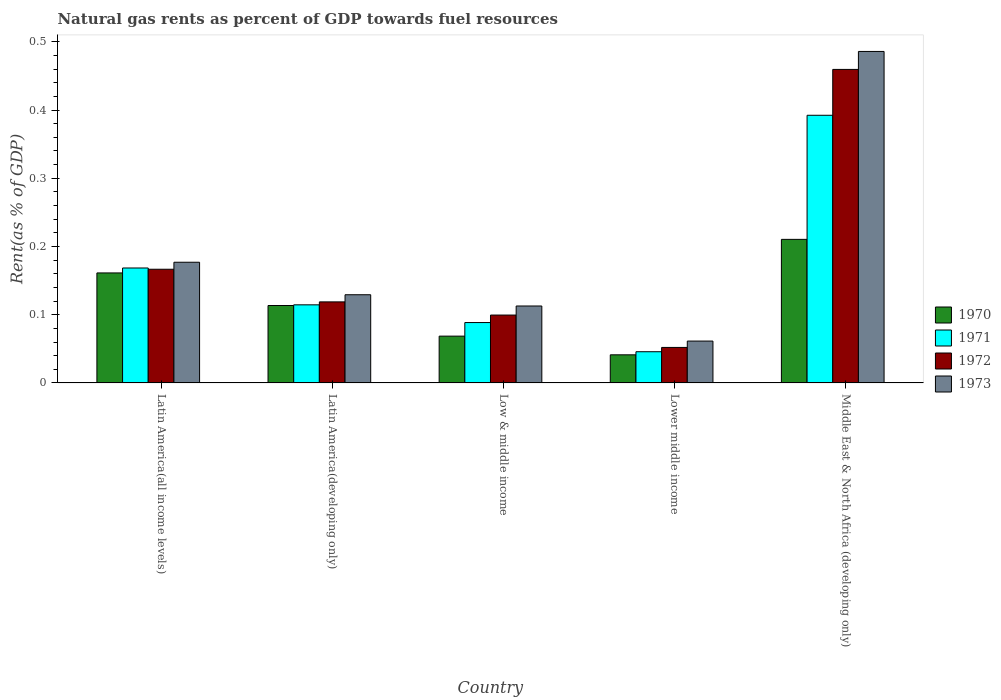Are the number of bars per tick equal to the number of legend labels?
Give a very brief answer. Yes. Are the number of bars on each tick of the X-axis equal?
Your answer should be compact. Yes. How many bars are there on the 4th tick from the left?
Offer a terse response. 4. How many bars are there on the 5th tick from the right?
Provide a short and direct response. 4. What is the label of the 5th group of bars from the left?
Your answer should be very brief. Middle East & North Africa (developing only). What is the matural gas rent in 1971 in Latin America(all income levels)?
Your answer should be very brief. 0.17. Across all countries, what is the maximum matural gas rent in 1972?
Give a very brief answer. 0.46. Across all countries, what is the minimum matural gas rent in 1971?
Offer a terse response. 0.05. In which country was the matural gas rent in 1972 maximum?
Ensure brevity in your answer.  Middle East & North Africa (developing only). In which country was the matural gas rent in 1973 minimum?
Provide a succinct answer. Lower middle income. What is the total matural gas rent in 1970 in the graph?
Your answer should be compact. 0.6. What is the difference between the matural gas rent in 1973 in Latin America(developing only) and that in Middle East & North Africa (developing only)?
Your answer should be very brief. -0.36. What is the difference between the matural gas rent in 1973 in Latin America(all income levels) and the matural gas rent in 1970 in Low & middle income?
Your answer should be compact. 0.11. What is the average matural gas rent in 1970 per country?
Ensure brevity in your answer.  0.12. What is the difference between the matural gas rent of/in 1971 and matural gas rent of/in 1973 in Latin America(all income levels)?
Offer a terse response. -0.01. In how many countries, is the matural gas rent in 1970 greater than 0.48000000000000004 %?
Your response must be concise. 0. What is the ratio of the matural gas rent in 1971 in Low & middle income to that in Middle East & North Africa (developing only)?
Your answer should be compact. 0.23. What is the difference between the highest and the second highest matural gas rent in 1972?
Your answer should be very brief. 0.34. What is the difference between the highest and the lowest matural gas rent in 1970?
Keep it short and to the point. 0.17. Is the sum of the matural gas rent in 1972 in Latin America(developing only) and Lower middle income greater than the maximum matural gas rent in 1971 across all countries?
Ensure brevity in your answer.  No. Is it the case that in every country, the sum of the matural gas rent in 1971 and matural gas rent in 1972 is greater than the sum of matural gas rent in 1973 and matural gas rent in 1970?
Provide a short and direct response. No. What does the 4th bar from the left in Lower middle income represents?
Offer a terse response. 1973. What does the 4th bar from the right in Latin America(developing only) represents?
Offer a terse response. 1970. Is it the case that in every country, the sum of the matural gas rent in 1971 and matural gas rent in 1970 is greater than the matural gas rent in 1972?
Provide a succinct answer. Yes. How many bars are there?
Your response must be concise. 20. How many countries are there in the graph?
Make the answer very short. 5. What is the difference between two consecutive major ticks on the Y-axis?
Make the answer very short. 0.1. Does the graph contain grids?
Your answer should be compact. No. Where does the legend appear in the graph?
Your response must be concise. Center right. How many legend labels are there?
Provide a succinct answer. 4. How are the legend labels stacked?
Offer a terse response. Vertical. What is the title of the graph?
Your answer should be compact. Natural gas rents as percent of GDP towards fuel resources. What is the label or title of the Y-axis?
Provide a succinct answer. Rent(as % of GDP). What is the Rent(as % of GDP) in 1970 in Latin America(all income levels)?
Your response must be concise. 0.16. What is the Rent(as % of GDP) in 1971 in Latin America(all income levels)?
Offer a very short reply. 0.17. What is the Rent(as % of GDP) of 1972 in Latin America(all income levels)?
Keep it short and to the point. 0.17. What is the Rent(as % of GDP) of 1973 in Latin America(all income levels)?
Provide a succinct answer. 0.18. What is the Rent(as % of GDP) of 1970 in Latin America(developing only)?
Make the answer very short. 0.11. What is the Rent(as % of GDP) in 1971 in Latin America(developing only)?
Give a very brief answer. 0.11. What is the Rent(as % of GDP) of 1972 in Latin America(developing only)?
Your answer should be very brief. 0.12. What is the Rent(as % of GDP) of 1973 in Latin America(developing only)?
Ensure brevity in your answer.  0.13. What is the Rent(as % of GDP) in 1970 in Low & middle income?
Your answer should be compact. 0.07. What is the Rent(as % of GDP) in 1971 in Low & middle income?
Make the answer very short. 0.09. What is the Rent(as % of GDP) in 1972 in Low & middle income?
Your answer should be very brief. 0.1. What is the Rent(as % of GDP) in 1973 in Low & middle income?
Give a very brief answer. 0.11. What is the Rent(as % of GDP) of 1970 in Lower middle income?
Give a very brief answer. 0.04. What is the Rent(as % of GDP) in 1971 in Lower middle income?
Keep it short and to the point. 0.05. What is the Rent(as % of GDP) of 1972 in Lower middle income?
Provide a short and direct response. 0.05. What is the Rent(as % of GDP) in 1973 in Lower middle income?
Offer a terse response. 0.06. What is the Rent(as % of GDP) in 1970 in Middle East & North Africa (developing only)?
Keep it short and to the point. 0.21. What is the Rent(as % of GDP) in 1971 in Middle East & North Africa (developing only)?
Your response must be concise. 0.39. What is the Rent(as % of GDP) in 1972 in Middle East & North Africa (developing only)?
Give a very brief answer. 0.46. What is the Rent(as % of GDP) of 1973 in Middle East & North Africa (developing only)?
Keep it short and to the point. 0.49. Across all countries, what is the maximum Rent(as % of GDP) of 1970?
Provide a succinct answer. 0.21. Across all countries, what is the maximum Rent(as % of GDP) of 1971?
Provide a succinct answer. 0.39. Across all countries, what is the maximum Rent(as % of GDP) in 1972?
Your response must be concise. 0.46. Across all countries, what is the maximum Rent(as % of GDP) in 1973?
Offer a very short reply. 0.49. Across all countries, what is the minimum Rent(as % of GDP) of 1970?
Offer a very short reply. 0.04. Across all countries, what is the minimum Rent(as % of GDP) in 1971?
Make the answer very short. 0.05. Across all countries, what is the minimum Rent(as % of GDP) in 1972?
Provide a succinct answer. 0.05. Across all countries, what is the minimum Rent(as % of GDP) of 1973?
Offer a very short reply. 0.06. What is the total Rent(as % of GDP) in 1970 in the graph?
Provide a short and direct response. 0.59. What is the total Rent(as % of GDP) in 1971 in the graph?
Provide a succinct answer. 0.81. What is the total Rent(as % of GDP) in 1972 in the graph?
Provide a succinct answer. 0.9. What is the total Rent(as % of GDP) in 1973 in the graph?
Your answer should be compact. 0.97. What is the difference between the Rent(as % of GDP) in 1970 in Latin America(all income levels) and that in Latin America(developing only)?
Keep it short and to the point. 0.05. What is the difference between the Rent(as % of GDP) in 1971 in Latin America(all income levels) and that in Latin America(developing only)?
Ensure brevity in your answer.  0.05. What is the difference between the Rent(as % of GDP) in 1972 in Latin America(all income levels) and that in Latin America(developing only)?
Provide a short and direct response. 0.05. What is the difference between the Rent(as % of GDP) in 1973 in Latin America(all income levels) and that in Latin America(developing only)?
Offer a very short reply. 0.05. What is the difference between the Rent(as % of GDP) of 1970 in Latin America(all income levels) and that in Low & middle income?
Offer a very short reply. 0.09. What is the difference between the Rent(as % of GDP) of 1971 in Latin America(all income levels) and that in Low & middle income?
Offer a terse response. 0.08. What is the difference between the Rent(as % of GDP) in 1972 in Latin America(all income levels) and that in Low & middle income?
Ensure brevity in your answer.  0.07. What is the difference between the Rent(as % of GDP) of 1973 in Latin America(all income levels) and that in Low & middle income?
Your answer should be compact. 0.06. What is the difference between the Rent(as % of GDP) of 1970 in Latin America(all income levels) and that in Lower middle income?
Offer a terse response. 0.12. What is the difference between the Rent(as % of GDP) of 1971 in Latin America(all income levels) and that in Lower middle income?
Your answer should be very brief. 0.12. What is the difference between the Rent(as % of GDP) of 1972 in Latin America(all income levels) and that in Lower middle income?
Make the answer very short. 0.11. What is the difference between the Rent(as % of GDP) of 1973 in Latin America(all income levels) and that in Lower middle income?
Offer a very short reply. 0.12. What is the difference between the Rent(as % of GDP) in 1970 in Latin America(all income levels) and that in Middle East & North Africa (developing only)?
Give a very brief answer. -0.05. What is the difference between the Rent(as % of GDP) of 1971 in Latin America(all income levels) and that in Middle East & North Africa (developing only)?
Your response must be concise. -0.22. What is the difference between the Rent(as % of GDP) of 1972 in Latin America(all income levels) and that in Middle East & North Africa (developing only)?
Keep it short and to the point. -0.29. What is the difference between the Rent(as % of GDP) of 1973 in Latin America(all income levels) and that in Middle East & North Africa (developing only)?
Keep it short and to the point. -0.31. What is the difference between the Rent(as % of GDP) in 1970 in Latin America(developing only) and that in Low & middle income?
Your answer should be compact. 0.04. What is the difference between the Rent(as % of GDP) in 1971 in Latin America(developing only) and that in Low & middle income?
Your answer should be very brief. 0.03. What is the difference between the Rent(as % of GDP) of 1972 in Latin America(developing only) and that in Low & middle income?
Offer a very short reply. 0.02. What is the difference between the Rent(as % of GDP) in 1973 in Latin America(developing only) and that in Low & middle income?
Provide a short and direct response. 0.02. What is the difference between the Rent(as % of GDP) of 1970 in Latin America(developing only) and that in Lower middle income?
Ensure brevity in your answer.  0.07. What is the difference between the Rent(as % of GDP) in 1971 in Latin America(developing only) and that in Lower middle income?
Provide a short and direct response. 0.07. What is the difference between the Rent(as % of GDP) in 1972 in Latin America(developing only) and that in Lower middle income?
Your response must be concise. 0.07. What is the difference between the Rent(as % of GDP) in 1973 in Latin America(developing only) and that in Lower middle income?
Provide a succinct answer. 0.07. What is the difference between the Rent(as % of GDP) in 1970 in Latin America(developing only) and that in Middle East & North Africa (developing only)?
Offer a terse response. -0.1. What is the difference between the Rent(as % of GDP) in 1971 in Latin America(developing only) and that in Middle East & North Africa (developing only)?
Give a very brief answer. -0.28. What is the difference between the Rent(as % of GDP) in 1972 in Latin America(developing only) and that in Middle East & North Africa (developing only)?
Give a very brief answer. -0.34. What is the difference between the Rent(as % of GDP) in 1973 in Latin America(developing only) and that in Middle East & North Africa (developing only)?
Offer a very short reply. -0.36. What is the difference between the Rent(as % of GDP) in 1970 in Low & middle income and that in Lower middle income?
Provide a short and direct response. 0.03. What is the difference between the Rent(as % of GDP) in 1971 in Low & middle income and that in Lower middle income?
Your answer should be compact. 0.04. What is the difference between the Rent(as % of GDP) in 1972 in Low & middle income and that in Lower middle income?
Give a very brief answer. 0.05. What is the difference between the Rent(as % of GDP) in 1973 in Low & middle income and that in Lower middle income?
Your answer should be very brief. 0.05. What is the difference between the Rent(as % of GDP) of 1970 in Low & middle income and that in Middle East & North Africa (developing only)?
Offer a very short reply. -0.14. What is the difference between the Rent(as % of GDP) in 1971 in Low & middle income and that in Middle East & North Africa (developing only)?
Your answer should be very brief. -0.3. What is the difference between the Rent(as % of GDP) of 1972 in Low & middle income and that in Middle East & North Africa (developing only)?
Offer a very short reply. -0.36. What is the difference between the Rent(as % of GDP) in 1973 in Low & middle income and that in Middle East & North Africa (developing only)?
Your answer should be compact. -0.37. What is the difference between the Rent(as % of GDP) in 1970 in Lower middle income and that in Middle East & North Africa (developing only)?
Offer a very short reply. -0.17. What is the difference between the Rent(as % of GDP) in 1971 in Lower middle income and that in Middle East & North Africa (developing only)?
Give a very brief answer. -0.35. What is the difference between the Rent(as % of GDP) in 1972 in Lower middle income and that in Middle East & North Africa (developing only)?
Make the answer very short. -0.41. What is the difference between the Rent(as % of GDP) of 1973 in Lower middle income and that in Middle East & North Africa (developing only)?
Make the answer very short. -0.42. What is the difference between the Rent(as % of GDP) of 1970 in Latin America(all income levels) and the Rent(as % of GDP) of 1971 in Latin America(developing only)?
Your answer should be compact. 0.05. What is the difference between the Rent(as % of GDP) in 1970 in Latin America(all income levels) and the Rent(as % of GDP) in 1972 in Latin America(developing only)?
Your answer should be compact. 0.04. What is the difference between the Rent(as % of GDP) in 1970 in Latin America(all income levels) and the Rent(as % of GDP) in 1973 in Latin America(developing only)?
Give a very brief answer. 0.03. What is the difference between the Rent(as % of GDP) of 1971 in Latin America(all income levels) and the Rent(as % of GDP) of 1972 in Latin America(developing only)?
Provide a short and direct response. 0.05. What is the difference between the Rent(as % of GDP) in 1971 in Latin America(all income levels) and the Rent(as % of GDP) in 1973 in Latin America(developing only)?
Keep it short and to the point. 0.04. What is the difference between the Rent(as % of GDP) in 1972 in Latin America(all income levels) and the Rent(as % of GDP) in 1973 in Latin America(developing only)?
Your response must be concise. 0.04. What is the difference between the Rent(as % of GDP) of 1970 in Latin America(all income levels) and the Rent(as % of GDP) of 1971 in Low & middle income?
Your answer should be very brief. 0.07. What is the difference between the Rent(as % of GDP) in 1970 in Latin America(all income levels) and the Rent(as % of GDP) in 1972 in Low & middle income?
Offer a terse response. 0.06. What is the difference between the Rent(as % of GDP) in 1970 in Latin America(all income levels) and the Rent(as % of GDP) in 1973 in Low & middle income?
Ensure brevity in your answer.  0.05. What is the difference between the Rent(as % of GDP) in 1971 in Latin America(all income levels) and the Rent(as % of GDP) in 1972 in Low & middle income?
Provide a short and direct response. 0.07. What is the difference between the Rent(as % of GDP) in 1971 in Latin America(all income levels) and the Rent(as % of GDP) in 1973 in Low & middle income?
Make the answer very short. 0.06. What is the difference between the Rent(as % of GDP) in 1972 in Latin America(all income levels) and the Rent(as % of GDP) in 1973 in Low & middle income?
Give a very brief answer. 0.05. What is the difference between the Rent(as % of GDP) of 1970 in Latin America(all income levels) and the Rent(as % of GDP) of 1971 in Lower middle income?
Offer a very short reply. 0.12. What is the difference between the Rent(as % of GDP) in 1970 in Latin America(all income levels) and the Rent(as % of GDP) in 1972 in Lower middle income?
Your response must be concise. 0.11. What is the difference between the Rent(as % of GDP) of 1970 in Latin America(all income levels) and the Rent(as % of GDP) of 1973 in Lower middle income?
Offer a terse response. 0.1. What is the difference between the Rent(as % of GDP) in 1971 in Latin America(all income levels) and the Rent(as % of GDP) in 1972 in Lower middle income?
Offer a very short reply. 0.12. What is the difference between the Rent(as % of GDP) in 1971 in Latin America(all income levels) and the Rent(as % of GDP) in 1973 in Lower middle income?
Your answer should be very brief. 0.11. What is the difference between the Rent(as % of GDP) of 1972 in Latin America(all income levels) and the Rent(as % of GDP) of 1973 in Lower middle income?
Ensure brevity in your answer.  0.11. What is the difference between the Rent(as % of GDP) of 1970 in Latin America(all income levels) and the Rent(as % of GDP) of 1971 in Middle East & North Africa (developing only)?
Offer a very short reply. -0.23. What is the difference between the Rent(as % of GDP) in 1970 in Latin America(all income levels) and the Rent(as % of GDP) in 1972 in Middle East & North Africa (developing only)?
Ensure brevity in your answer.  -0.3. What is the difference between the Rent(as % of GDP) in 1970 in Latin America(all income levels) and the Rent(as % of GDP) in 1973 in Middle East & North Africa (developing only)?
Offer a terse response. -0.32. What is the difference between the Rent(as % of GDP) of 1971 in Latin America(all income levels) and the Rent(as % of GDP) of 1972 in Middle East & North Africa (developing only)?
Offer a terse response. -0.29. What is the difference between the Rent(as % of GDP) of 1971 in Latin America(all income levels) and the Rent(as % of GDP) of 1973 in Middle East & North Africa (developing only)?
Give a very brief answer. -0.32. What is the difference between the Rent(as % of GDP) of 1972 in Latin America(all income levels) and the Rent(as % of GDP) of 1973 in Middle East & North Africa (developing only)?
Ensure brevity in your answer.  -0.32. What is the difference between the Rent(as % of GDP) of 1970 in Latin America(developing only) and the Rent(as % of GDP) of 1971 in Low & middle income?
Offer a very short reply. 0.03. What is the difference between the Rent(as % of GDP) of 1970 in Latin America(developing only) and the Rent(as % of GDP) of 1972 in Low & middle income?
Keep it short and to the point. 0.01. What is the difference between the Rent(as % of GDP) in 1970 in Latin America(developing only) and the Rent(as % of GDP) in 1973 in Low & middle income?
Offer a very short reply. 0. What is the difference between the Rent(as % of GDP) in 1971 in Latin America(developing only) and the Rent(as % of GDP) in 1972 in Low & middle income?
Offer a very short reply. 0.01. What is the difference between the Rent(as % of GDP) of 1971 in Latin America(developing only) and the Rent(as % of GDP) of 1973 in Low & middle income?
Offer a very short reply. 0. What is the difference between the Rent(as % of GDP) of 1972 in Latin America(developing only) and the Rent(as % of GDP) of 1973 in Low & middle income?
Give a very brief answer. 0.01. What is the difference between the Rent(as % of GDP) of 1970 in Latin America(developing only) and the Rent(as % of GDP) of 1971 in Lower middle income?
Your answer should be very brief. 0.07. What is the difference between the Rent(as % of GDP) of 1970 in Latin America(developing only) and the Rent(as % of GDP) of 1972 in Lower middle income?
Your response must be concise. 0.06. What is the difference between the Rent(as % of GDP) in 1970 in Latin America(developing only) and the Rent(as % of GDP) in 1973 in Lower middle income?
Keep it short and to the point. 0.05. What is the difference between the Rent(as % of GDP) of 1971 in Latin America(developing only) and the Rent(as % of GDP) of 1972 in Lower middle income?
Ensure brevity in your answer.  0.06. What is the difference between the Rent(as % of GDP) in 1971 in Latin America(developing only) and the Rent(as % of GDP) in 1973 in Lower middle income?
Make the answer very short. 0.05. What is the difference between the Rent(as % of GDP) in 1972 in Latin America(developing only) and the Rent(as % of GDP) in 1973 in Lower middle income?
Offer a terse response. 0.06. What is the difference between the Rent(as % of GDP) in 1970 in Latin America(developing only) and the Rent(as % of GDP) in 1971 in Middle East & North Africa (developing only)?
Provide a short and direct response. -0.28. What is the difference between the Rent(as % of GDP) of 1970 in Latin America(developing only) and the Rent(as % of GDP) of 1972 in Middle East & North Africa (developing only)?
Give a very brief answer. -0.35. What is the difference between the Rent(as % of GDP) of 1970 in Latin America(developing only) and the Rent(as % of GDP) of 1973 in Middle East & North Africa (developing only)?
Ensure brevity in your answer.  -0.37. What is the difference between the Rent(as % of GDP) of 1971 in Latin America(developing only) and the Rent(as % of GDP) of 1972 in Middle East & North Africa (developing only)?
Make the answer very short. -0.35. What is the difference between the Rent(as % of GDP) of 1971 in Latin America(developing only) and the Rent(as % of GDP) of 1973 in Middle East & North Africa (developing only)?
Your answer should be very brief. -0.37. What is the difference between the Rent(as % of GDP) in 1972 in Latin America(developing only) and the Rent(as % of GDP) in 1973 in Middle East & North Africa (developing only)?
Offer a very short reply. -0.37. What is the difference between the Rent(as % of GDP) in 1970 in Low & middle income and the Rent(as % of GDP) in 1971 in Lower middle income?
Your answer should be compact. 0.02. What is the difference between the Rent(as % of GDP) in 1970 in Low & middle income and the Rent(as % of GDP) in 1972 in Lower middle income?
Your answer should be very brief. 0.02. What is the difference between the Rent(as % of GDP) of 1970 in Low & middle income and the Rent(as % of GDP) of 1973 in Lower middle income?
Make the answer very short. 0.01. What is the difference between the Rent(as % of GDP) of 1971 in Low & middle income and the Rent(as % of GDP) of 1972 in Lower middle income?
Keep it short and to the point. 0.04. What is the difference between the Rent(as % of GDP) in 1971 in Low & middle income and the Rent(as % of GDP) in 1973 in Lower middle income?
Your answer should be compact. 0.03. What is the difference between the Rent(as % of GDP) in 1972 in Low & middle income and the Rent(as % of GDP) in 1973 in Lower middle income?
Offer a terse response. 0.04. What is the difference between the Rent(as % of GDP) of 1970 in Low & middle income and the Rent(as % of GDP) of 1971 in Middle East & North Africa (developing only)?
Make the answer very short. -0.32. What is the difference between the Rent(as % of GDP) in 1970 in Low & middle income and the Rent(as % of GDP) in 1972 in Middle East & North Africa (developing only)?
Offer a terse response. -0.39. What is the difference between the Rent(as % of GDP) of 1970 in Low & middle income and the Rent(as % of GDP) of 1973 in Middle East & North Africa (developing only)?
Make the answer very short. -0.42. What is the difference between the Rent(as % of GDP) in 1971 in Low & middle income and the Rent(as % of GDP) in 1972 in Middle East & North Africa (developing only)?
Your response must be concise. -0.37. What is the difference between the Rent(as % of GDP) of 1971 in Low & middle income and the Rent(as % of GDP) of 1973 in Middle East & North Africa (developing only)?
Your answer should be compact. -0.4. What is the difference between the Rent(as % of GDP) in 1972 in Low & middle income and the Rent(as % of GDP) in 1973 in Middle East & North Africa (developing only)?
Your answer should be compact. -0.39. What is the difference between the Rent(as % of GDP) in 1970 in Lower middle income and the Rent(as % of GDP) in 1971 in Middle East & North Africa (developing only)?
Your response must be concise. -0.35. What is the difference between the Rent(as % of GDP) of 1970 in Lower middle income and the Rent(as % of GDP) of 1972 in Middle East & North Africa (developing only)?
Make the answer very short. -0.42. What is the difference between the Rent(as % of GDP) in 1970 in Lower middle income and the Rent(as % of GDP) in 1973 in Middle East & North Africa (developing only)?
Give a very brief answer. -0.44. What is the difference between the Rent(as % of GDP) of 1971 in Lower middle income and the Rent(as % of GDP) of 1972 in Middle East & North Africa (developing only)?
Offer a terse response. -0.41. What is the difference between the Rent(as % of GDP) in 1971 in Lower middle income and the Rent(as % of GDP) in 1973 in Middle East & North Africa (developing only)?
Make the answer very short. -0.44. What is the difference between the Rent(as % of GDP) of 1972 in Lower middle income and the Rent(as % of GDP) of 1973 in Middle East & North Africa (developing only)?
Keep it short and to the point. -0.43. What is the average Rent(as % of GDP) of 1970 per country?
Offer a very short reply. 0.12. What is the average Rent(as % of GDP) of 1971 per country?
Offer a terse response. 0.16. What is the average Rent(as % of GDP) in 1972 per country?
Ensure brevity in your answer.  0.18. What is the average Rent(as % of GDP) in 1973 per country?
Give a very brief answer. 0.19. What is the difference between the Rent(as % of GDP) in 1970 and Rent(as % of GDP) in 1971 in Latin America(all income levels)?
Make the answer very short. -0.01. What is the difference between the Rent(as % of GDP) of 1970 and Rent(as % of GDP) of 1972 in Latin America(all income levels)?
Offer a very short reply. -0.01. What is the difference between the Rent(as % of GDP) of 1970 and Rent(as % of GDP) of 1973 in Latin America(all income levels)?
Keep it short and to the point. -0.02. What is the difference between the Rent(as % of GDP) in 1971 and Rent(as % of GDP) in 1972 in Latin America(all income levels)?
Provide a short and direct response. 0. What is the difference between the Rent(as % of GDP) of 1971 and Rent(as % of GDP) of 1973 in Latin America(all income levels)?
Provide a short and direct response. -0.01. What is the difference between the Rent(as % of GDP) in 1972 and Rent(as % of GDP) in 1973 in Latin America(all income levels)?
Your answer should be compact. -0.01. What is the difference between the Rent(as % of GDP) in 1970 and Rent(as % of GDP) in 1971 in Latin America(developing only)?
Offer a terse response. -0. What is the difference between the Rent(as % of GDP) in 1970 and Rent(as % of GDP) in 1972 in Latin America(developing only)?
Offer a very short reply. -0.01. What is the difference between the Rent(as % of GDP) in 1970 and Rent(as % of GDP) in 1973 in Latin America(developing only)?
Offer a very short reply. -0.02. What is the difference between the Rent(as % of GDP) of 1971 and Rent(as % of GDP) of 1972 in Latin America(developing only)?
Provide a short and direct response. -0. What is the difference between the Rent(as % of GDP) of 1971 and Rent(as % of GDP) of 1973 in Latin America(developing only)?
Provide a short and direct response. -0.01. What is the difference between the Rent(as % of GDP) of 1972 and Rent(as % of GDP) of 1973 in Latin America(developing only)?
Provide a short and direct response. -0.01. What is the difference between the Rent(as % of GDP) in 1970 and Rent(as % of GDP) in 1971 in Low & middle income?
Your response must be concise. -0.02. What is the difference between the Rent(as % of GDP) in 1970 and Rent(as % of GDP) in 1972 in Low & middle income?
Your response must be concise. -0.03. What is the difference between the Rent(as % of GDP) of 1970 and Rent(as % of GDP) of 1973 in Low & middle income?
Provide a short and direct response. -0.04. What is the difference between the Rent(as % of GDP) in 1971 and Rent(as % of GDP) in 1972 in Low & middle income?
Keep it short and to the point. -0.01. What is the difference between the Rent(as % of GDP) of 1971 and Rent(as % of GDP) of 1973 in Low & middle income?
Give a very brief answer. -0.02. What is the difference between the Rent(as % of GDP) of 1972 and Rent(as % of GDP) of 1973 in Low & middle income?
Your answer should be very brief. -0.01. What is the difference between the Rent(as % of GDP) in 1970 and Rent(as % of GDP) in 1971 in Lower middle income?
Your answer should be compact. -0. What is the difference between the Rent(as % of GDP) of 1970 and Rent(as % of GDP) of 1972 in Lower middle income?
Offer a terse response. -0.01. What is the difference between the Rent(as % of GDP) in 1970 and Rent(as % of GDP) in 1973 in Lower middle income?
Your answer should be very brief. -0.02. What is the difference between the Rent(as % of GDP) in 1971 and Rent(as % of GDP) in 1972 in Lower middle income?
Your answer should be compact. -0.01. What is the difference between the Rent(as % of GDP) in 1971 and Rent(as % of GDP) in 1973 in Lower middle income?
Make the answer very short. -0.02. What is the difference between the Rent(as % of GDP) of 1972 and Rent(as % of GDP) of 1973 in Lower middle income?
Give a very brief answer. -0.01. What is the difference between the Rent(as % of GDP) of 1970 and Rent(as % of GDP) of 1971 in Middle East & North Africa (developing only)?
Give a very brief answer. -0.18. What is the difference between the Rent(as % of GDP) of 1970 and Rent(as % of GDP) of 1972 in Middle East & North Africa (developing only)?
Provide a short and direct response. -0.25. What is the difference between the Rent(as % of GDP) of 1970 and Rent(as % of GDP) of 1973 in Middle East & North Africa (developing only)?
Keep it short and to the point. -0.28. What is the difference between the Rent(as % of GDP) of 1971 and Rent(as % of GDP) of 1972 in Middle East & North Africa (developing only)?
Offer a very short reply. -0.07. What is the difference between the Rent(as % of GDP) of 1971 and Rent(as % of GDP) of 1973 in Middle East & North Africa (developing only)?
Give a very brief answer. -0.09. What is the difference between the Rent(as % of GDP) of 1972 and Rent(as % of GDP) of 1973 in Middle East & North Africa (developing only)?
Your response must be concise. -0.03. What is the ratio of the Rent(as % of GDP) in 1970 in Latin America(all income levels) to that in Latin America(developing only)?
Give a very brief answer. 1.42. What is the ratio of the Rent(as % of GDP) in 1971 in Latin America(all income levels) to that in Latin America(developing only)?
Provide a short and direct response. 1.47. What is the ratio of the Rent(as % of GDP) in 1972 in Latin America(all income levels) to that in Latin America(developing only)?
Ensure brevity in your answer.  1.4. What is the ratio of the Rent(as % of GDP) of 1973 in Latin America(all income levels) to that in Latin America(developing only)?
Your response must be concise. 1.37. What is the ratio of the Rent(as % of GDP) in 1970 in Latin America(all income levels) to that in Low & middle income?
Provide a succinct answer. 2.35. What is the ratio of the Rent(as % of GDP) of 1971 in Latin America(all income levels) to that in Low & middle income?
Give a very brief answer. 1.9. What is the ratio of the Rent(as % of GDP) in 1972 in Latin America(all income levels) to that in Low & middle income?
Provide a succinct answer. 1.67. What is the ratio of the Rent(as % of GDP) in 1973 in Latin America(all income levels) to that in Low & middle income?
Offer a terse response. 1.57. What is the ratio of the Rent(as % of GDP) of 1970 in Latin America(all income levels) to that in Lower middle income?
Give a very brief answer. 3.91. What is the ratio of the Rent(as % of GDP) in 1971 in Latin America(all income levels) to that in Lower middle income?
Provide a succinct answer. 3.68. What is the ratio of the Rent(as % of GDP) in 1972 in Latin America(all income levels) to that in Lower middle income?
Your response must be concise. 3.2. What is the ratio of the Rent(as % of GDP) of 1973 in Latin America(all income levels) to that in Lower middle income?
Your answer should be compact. 2.88. What is the ratio of the Rent(as % of GDP) of 1970 in Latin America(all income levels) to that in Middle East & North Africa (developing only)?
Give a very brief answer. 0.77. What is the ratio of the Rent(as % of GDP) in 1971 in Latin America(all income levels) to that in Middle East & North Africa (developing only)?
Make the answer very short. 0.43. What is the ratio of the Rent(as % of GDP) of 1972 in Latin America(all income levels) to that in Middle East & North Africa (developing only)?
Provide a succinct answer. 0.36. What is the ratio of the Rent(as % of GDP) in 1973 in Latin America(all income levels) to that in Middle East & North Africa (developing only)?
Ensure brevity in your answer.  0.36. What is the ratio of the Rent(as % of GDP) of 1970 in Latin America(developing only) to that in Low & middle income?
Your response must be concise. 1.65. What is the ratio of the Rent(as % of GDP) in 1971 in Latin America(developing only) to that in Low & middle income?
Your answer should be compact. 1.29. What is the ratio of the Rent(as % of GDP) of 1972 in Latin America(developing only) to that in Low & middle income?
Ensure brevity in your answer.  1.19. What is the ratio of the Rent(as % of GDP) of 1973 in Latin America(developing only) to that in Low & middle income?
Your answer should be compact. 1.15. What is the ratio of the Rent(as % of GDP) in 1970 in Latin America(developing only) to that in Lower middle income?
Ensure brevity in your answer.  2.75. What is the ratio of the Rent(as % of GDP) in 1971 in Latin America(developing only) to that in Lower middle income?
Make the answer very short. 2.5. What is the ratio of the Rent(as % of GDP) in 1972 in Latin America(developing only) to that in Lower middle income?
Ensure brevity in your answer.  2.28. What is the ratio of the Rent(as % of GDP) of 1973 in Latin America(developing only) to that in Lower middle income?
Your answer should be compact. 2.11. What is the ratio of the Rent(as % of GDP) in 1970 in Latin America(developing only) to that in Middle East & North Africa (developing only)?
Offer a very short reply. 0.54. What is the ratio of the Rent(as % of GDP) of 1971 in Latin America(developing only) to that in Middle East & North Africa (developing only)?
Provide a short and direct response. 0.29. What is the ratio of the Rent(as % of GDP) of 1972 in Latin America(developing only) to that in Middle East & North Africa (developing only)?
Make the answer very short. 0.26. What is the ratio of the Rent(as % of GDP) of 1973 in Latin America(developing only) to that in Middle East & North Africa (developing only)?
Your response must be concise. 0.27. What is the ratio of the Rent(as % of GDP) of 1970 in Low & middle income to that in Lower middle income?
Provide a short and direct response. 1.66. What is the ratio of the Rent(as % of GDP) of 1971 in Low & middle income to that in Lower middle income?
Your answer should be very brief. 1.93. What is the ratio of the Rent(as % of GDP) of 1972 in Low & middle income to that in Lower middle income?
Ensure brevity in your answer.  1.91. What is the ratio of the Rent(as % of GDP) of 1973 in Low & middle income to that in Lower middle income?
Provide a short and direct response. 1.84. What is the ratio of the Rent(as % of GDP) in 1970 in Low & middle income to that in Middle East & North Africa (developing only)?
Provide a succinct answer. 0.33. What is the ratio of the Rent(as % of GDP) in 1971 in Low & middle income to that in Middle East & North Africa (developing only)?
Offer a very short reply. 0.23. What is the ratio of the Rent(as % of GDP) in 1972 in Low & middle income to that in Middle East & North Africa (developing only)?
Your answer should be compact. 0.22. What is the ratio of the Rent(as % of GDP) of 1973 in Low & middle income to that in Middle East & North Africa (developing only)?
Make the answer very short. 0.23. What is the ratio of the Rent(as % of GDP) of 1970 in Lower middle income to that in Middle East & North Africa (developing only)?
Give a very brief answer. 0.2. What is the ratio of the Rent(as % of GDP) of 1971 in Lower middle income to that in Middle East & North Africa (developing only)?
Offer a very short reply. 0.12. What is the ratio of the Rent(as % of GDP) of 1972 in Lower middle income to that in Middle East & North Africa (developing only)?
Give a very brief answer. 0.11. What is the ratio of the Rent(as % of GDP) of 1973 in Lower middle income to that in Middle East & North Africa (developing only)?
Make the answer very short. 0.13. What is the difference between the highest and the second highest Rent(as % of GDP) of 1970?
Give a very brief answer. 0.05. What is the difference between the highest and the second highest Rent(as % of GDP) in 1971?
Ensure brevity in your answer.  0.22. What is the difference between the highest and the second highest Rent(as % of GDP) in 1972?
Keep it short and to the point. 0.29. What is the difference between the highest and the second highest Rent(as % of GDP) of 1973?
Provide a succinct answer. 0.31. What is the difference between the highest and the lowest Rent(as % of GDP) in 1970?
Provide a succinct answer. 0.17. What is the difference between the highest and the lowest Rent(as % of GDP) in 1971?
Give a very brief answer. 0.35. What is the difference between the highest and the lowest Rent(as % of GDP) in 1972?
Make the answer very short. 0.41. What is the difference between the highest and the lowest Rent(as % of GDP) of 1973?
Provide a succinct answer. 0.42. 